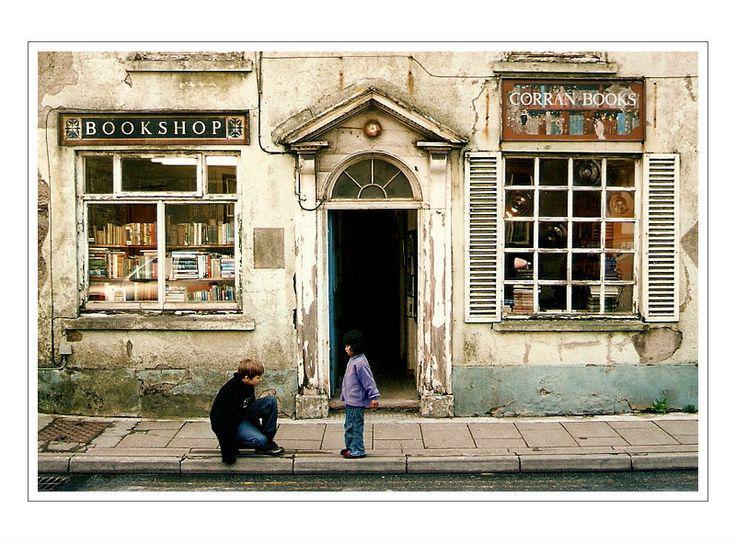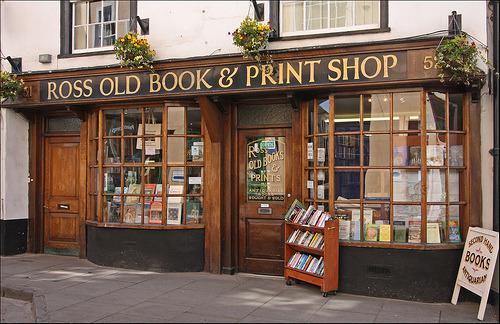The first image is the image on the left, the second image is the image on the right. Analyze the images presented: Is the assertion "The right image contains an outside view of a storefront." valid? Answer yes or no. Yes. The first image is the image on the left, the second image is the image on the right. For the images shown, is this caption "In this book store there is at least one person looking at  books from the shelve." true? Answer yes or no. No. 